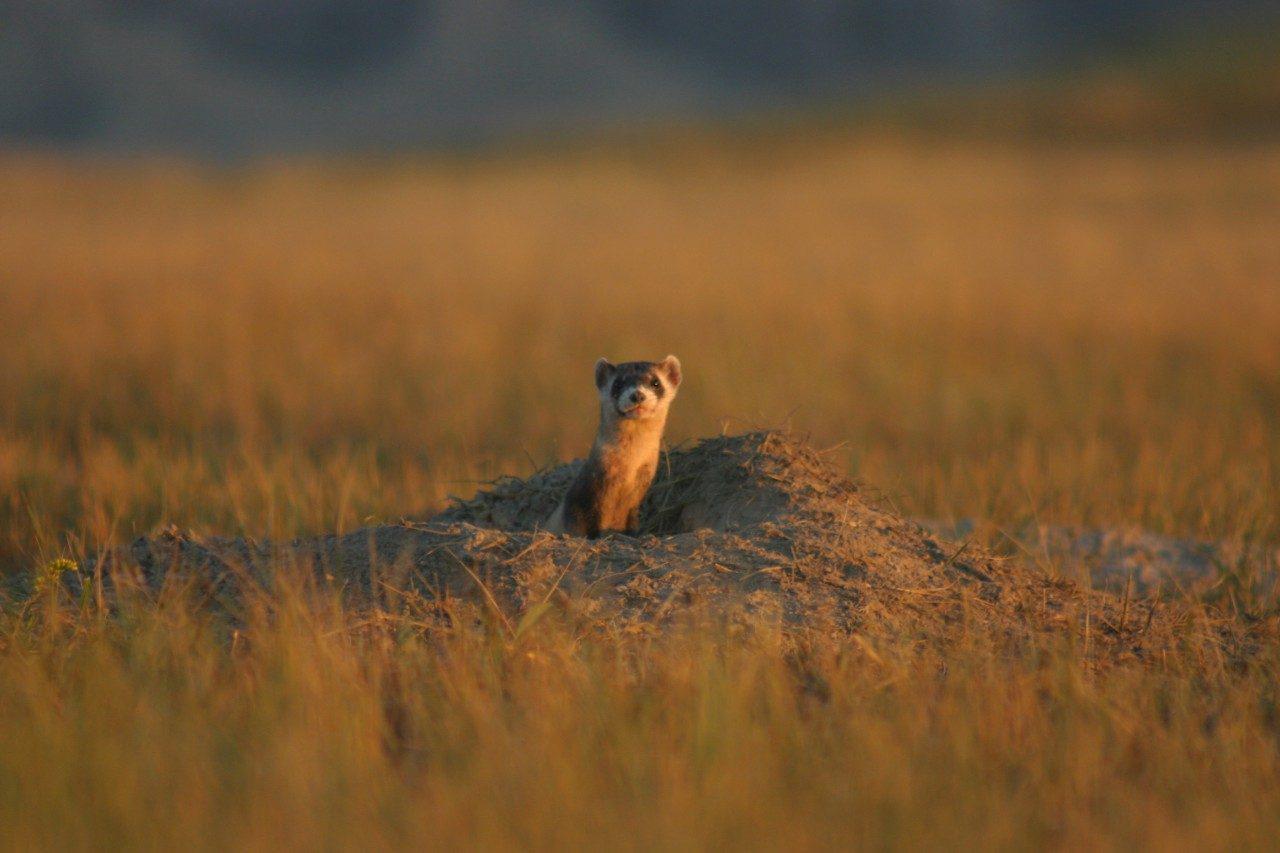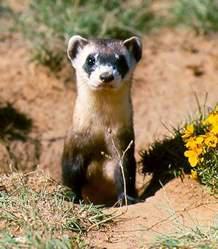The first image is the image on the left, the second image is the image on the right. For the images displayed, is the sentence "Right image shows at least one camera-facing ferret with upright body, emerging from a hole." factually correct? Answer yes or no. Yes. The first image is the image on the left, the second image is the image on the right. Analyze the images presented: Is the assertion "Prairie dogs pose together in the image on the right." valid? Answer yes or no. No. 